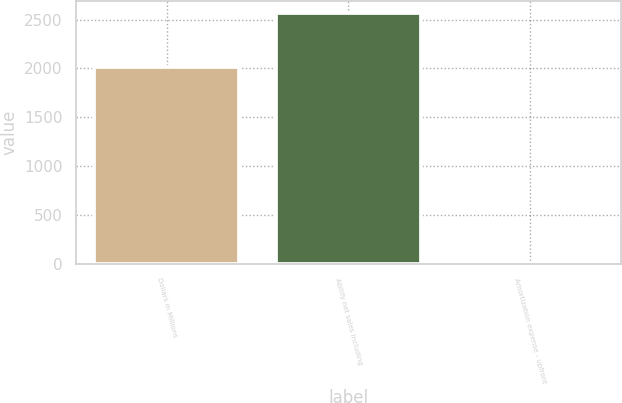Convert chart to OTSL. <chart><loc_0><loc_0><loc_500><loc_500><bar_chart><fcel>Dollars in Millions<fcel>Abilify net sales including<fcel>Amortization expense - upfront<nl><fcel>2010<fcel>2565<fcel>6<nl></chart> 